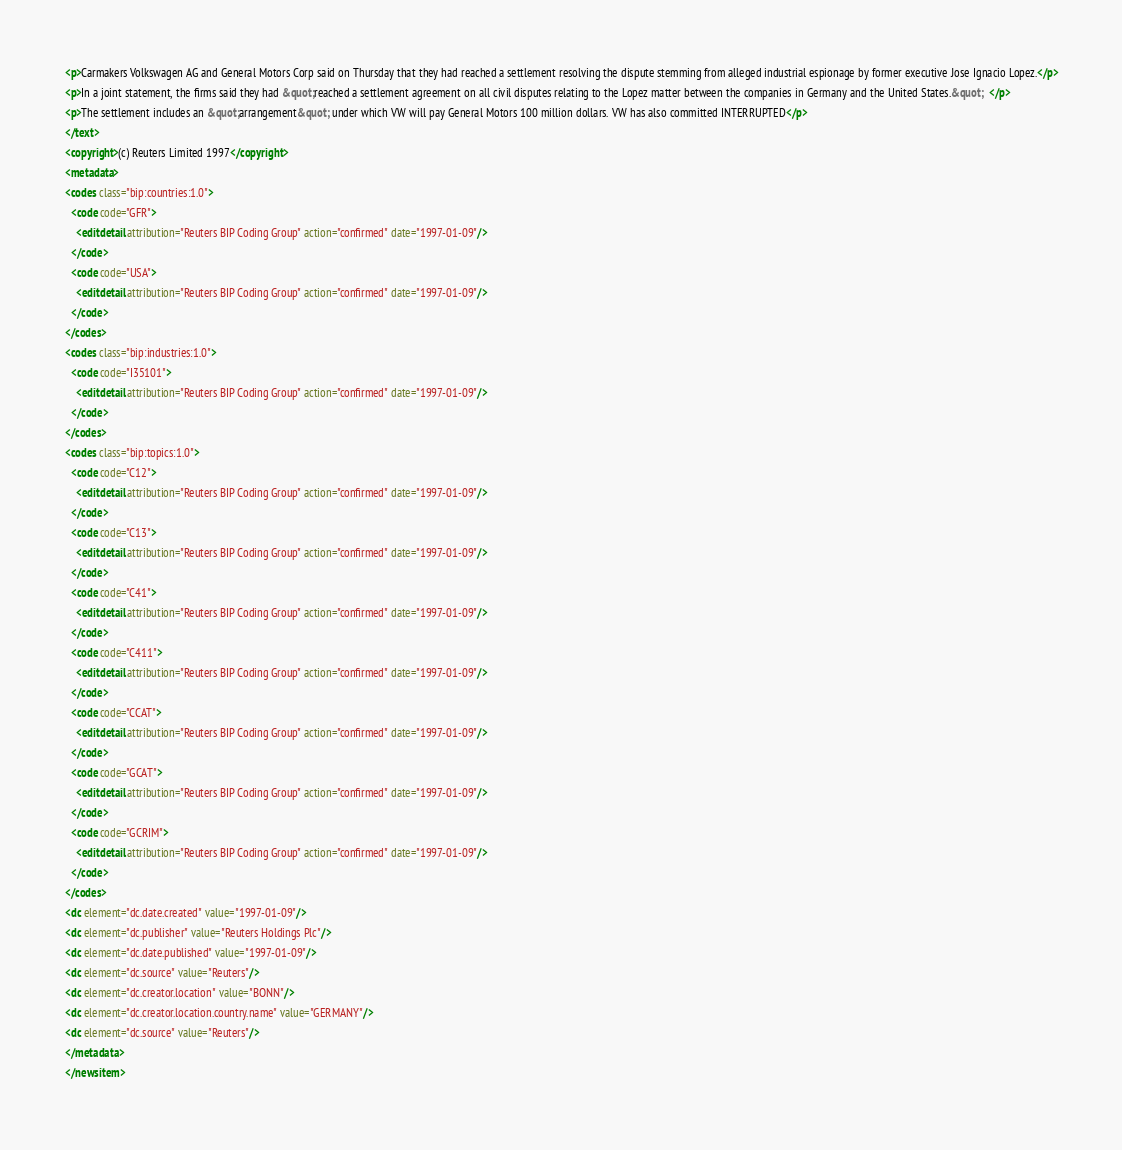Convert code to text. <code><loc_0><loc_0><loc_500><loc_500><_XML_><p>Carmakers Volkswagen AG and General Motors Corp said on Thursday that they had reached a settlement resolving the dispute stemming from alleged industrial espionage by former executive Jose Ignacio Lopez.</p>
<p>In a joint statement, the firms said they had &quot;reached a settlement agreement on all civil disputes relating to the Lopez matter between the companies in Germany and the United States.&quot;  </p>
<p>The settlement includes an &quot;arrangement&quot; under which VW will pay General Motors 100 million dollars. VW has also committed INTERRUPTED</p>
</text>
<copyright>(c) Reuters Limited 1997</copyright>
<metadata>
<codes class="bip:countries:1.0">
  <code code="GFR">
    <editdetail attribution="Reuters BIP Coding Group" action="confirmed" date="1997-01-09"/>
  </code>
  <code code="USA">
    <editdetail attribution="Reuters BIP Coding Group" action="confirmed" date="1997-01-09"/>
  </code>
</codes>
<codes class="bip:industries:1.0">
  <code code="I35101">
    <editdetail attribution="Reuters BIP Coding Group" action="confirmed" date="1997-01-09"/>
  </code>
</codes>
<codes class="bip:topics:1.0">
  <code code="C12">
    <editdetail attribution="Reuters BIP Coding Group" action="confirmed" date="1997-01-09"/>
  </code>
  <code code="C13">
    <editdetail attribution="Reuters BIP Coding Group" action="confirmed" date="1997-01-09"/>
  </code>
  <code code="C41">
    <editdetail attribution="Reuters BIP Coding Group" action="confirmed" date="1997-01-09"/>
  </code>
  <code code="C411">
    <editdetail attribution="Reuters BIP Coding Group" action="confirmed" date="1997-01-09"/>
  </code>
  <code code="CCAT">
    <editdetail attribution="Reuters BIP Coding Group" action="confirmed" date="1997-01-09"/>
  </code>
  <code code="GCAT">
    <editdetail attribution="Reuters BIP Coding Group" action="confirmed" date="1997-01-09"/>
  </code>
  <code code="GCRIM">
    <editdetail attribution="Reuters BIP Coding Group" action="confirmed" date="1997-01-09"/>
  </code>
</codes>
<dc element="dc.date.created" value="1997-01-09"/>
<dc element="dc.publisher" value="Reuters Holdings Plc"/>
<dc element="dc.date.published" value="1997-01-09"/>
<dc element="dc.source" value="Reuters"/>
<dc element="dc.creator.location" value="BONN"/>
<dc element="dc.creator.location.country.name" value="GERMANY"/>
<dc element="dc.source" value="Reuters"/>
</metadata>
</newsitem>
</code> 